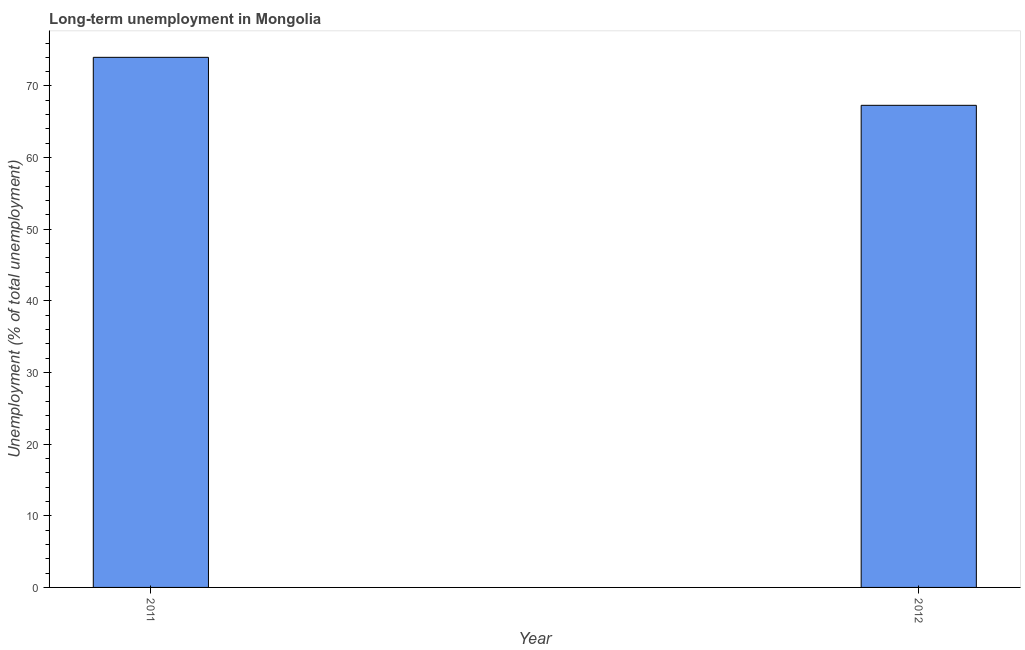Does the graph contain any zero values?
Your answer should be very brief. No. Does the graph contain grids?
Provide a succinct answer. No. What is the title of the graph?
Offer a very short reply. Long-term unemployment in Mongolia. What is the label or title of the Y-axis?
Your answer should be very brief. Unemployment (% of total unemployment). What is the long-term unemployment in 2012?
Keep it short and to the point. 67.3. Across all years, what is the maximum long-term unemployment?
Your response must be concise. 74. Across all years, what is the minimum long-term unemployment?
Provide a short and direct response. 67.3. What is the sum of the long-term unemployment?
Provide a short and direct response. 141.3. What is the difference between the long-term unemployment in 2011 and 2012?
Offer a terse response. 6.7. What is the average long-term unemployment per year?
Your response must be concise. 70.65. What is the median long-term unemployment?
Provide a succinct answer. 70.65. Do a majority of the years between 2011 and 2012 (inclusive) have long-term unemployment greater than 74 %?
Your answer should be compact. No. What is the ratio of the long-term unemployment in 2011 to that in 2012?
Ensure brevity in your answer.  1.1. Is the long-term unemployment in 2011 less than that in 2012?
Offer a terse response. No. In how many years, is the long-term unemployment greater than the average long-term unemployment taken over all years?
Make the answer very short. 1. How many bars are there?
Keep it short and to the point. 2. Are all the bars in the graph horizontal?
Your answer should be compact. No. How many years are there in the graph?
Give a very brief answer. 2. Are the values on the major ticks of Y-axis written in scientific E-notation?
Ensure brevity in your answer.  No. What is the Unemployment (% of total unemployment) of 2011?
Your answer should be compact. 74. What is the Unemployment (% of total unemployment) of 2012?
Provide a succinct answer. 67.3. What is the difference between the Unemployment (% of total unemployment) in 2011 and 2012?
Your response must be concise. 6.7. 